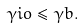Convert formula to latex. <formula><loc_0><loc_0><loc_500><loc_500>\gamma i o \leq \gamma b .</formula> 